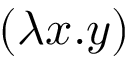<formula> <loc_0><loc_0><loc_500><loc_500>( \lambda x . y )</formula> 